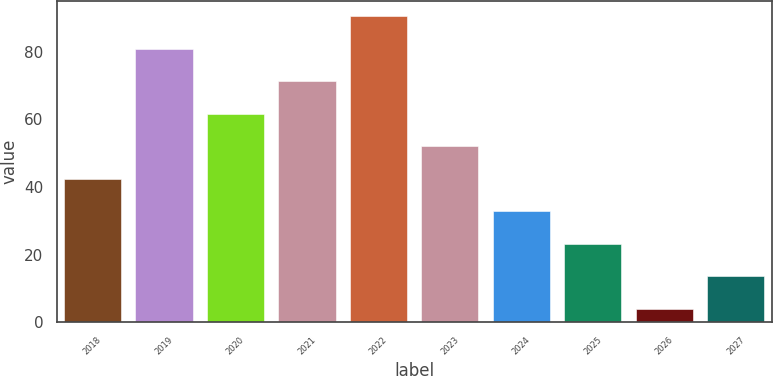Convert chart to OTSL. <chart><loc_0><loc_0><loc_500><loc_500><bar_chart><fcel>2018<fcel>2019<fcel>2020<fcel>2021<fcel>2022<fcel>2023<fcel>2024<fcel>2025<fcel>2026<fcel>2027<nl><fcel>42.4<fcel>80.8<fcel>61.6<fcel>71.2<fcel>90.4<fcel>52<fcel>32.8<fcel>23.2<fcel>4<fcel>13.6<nl></chart> 